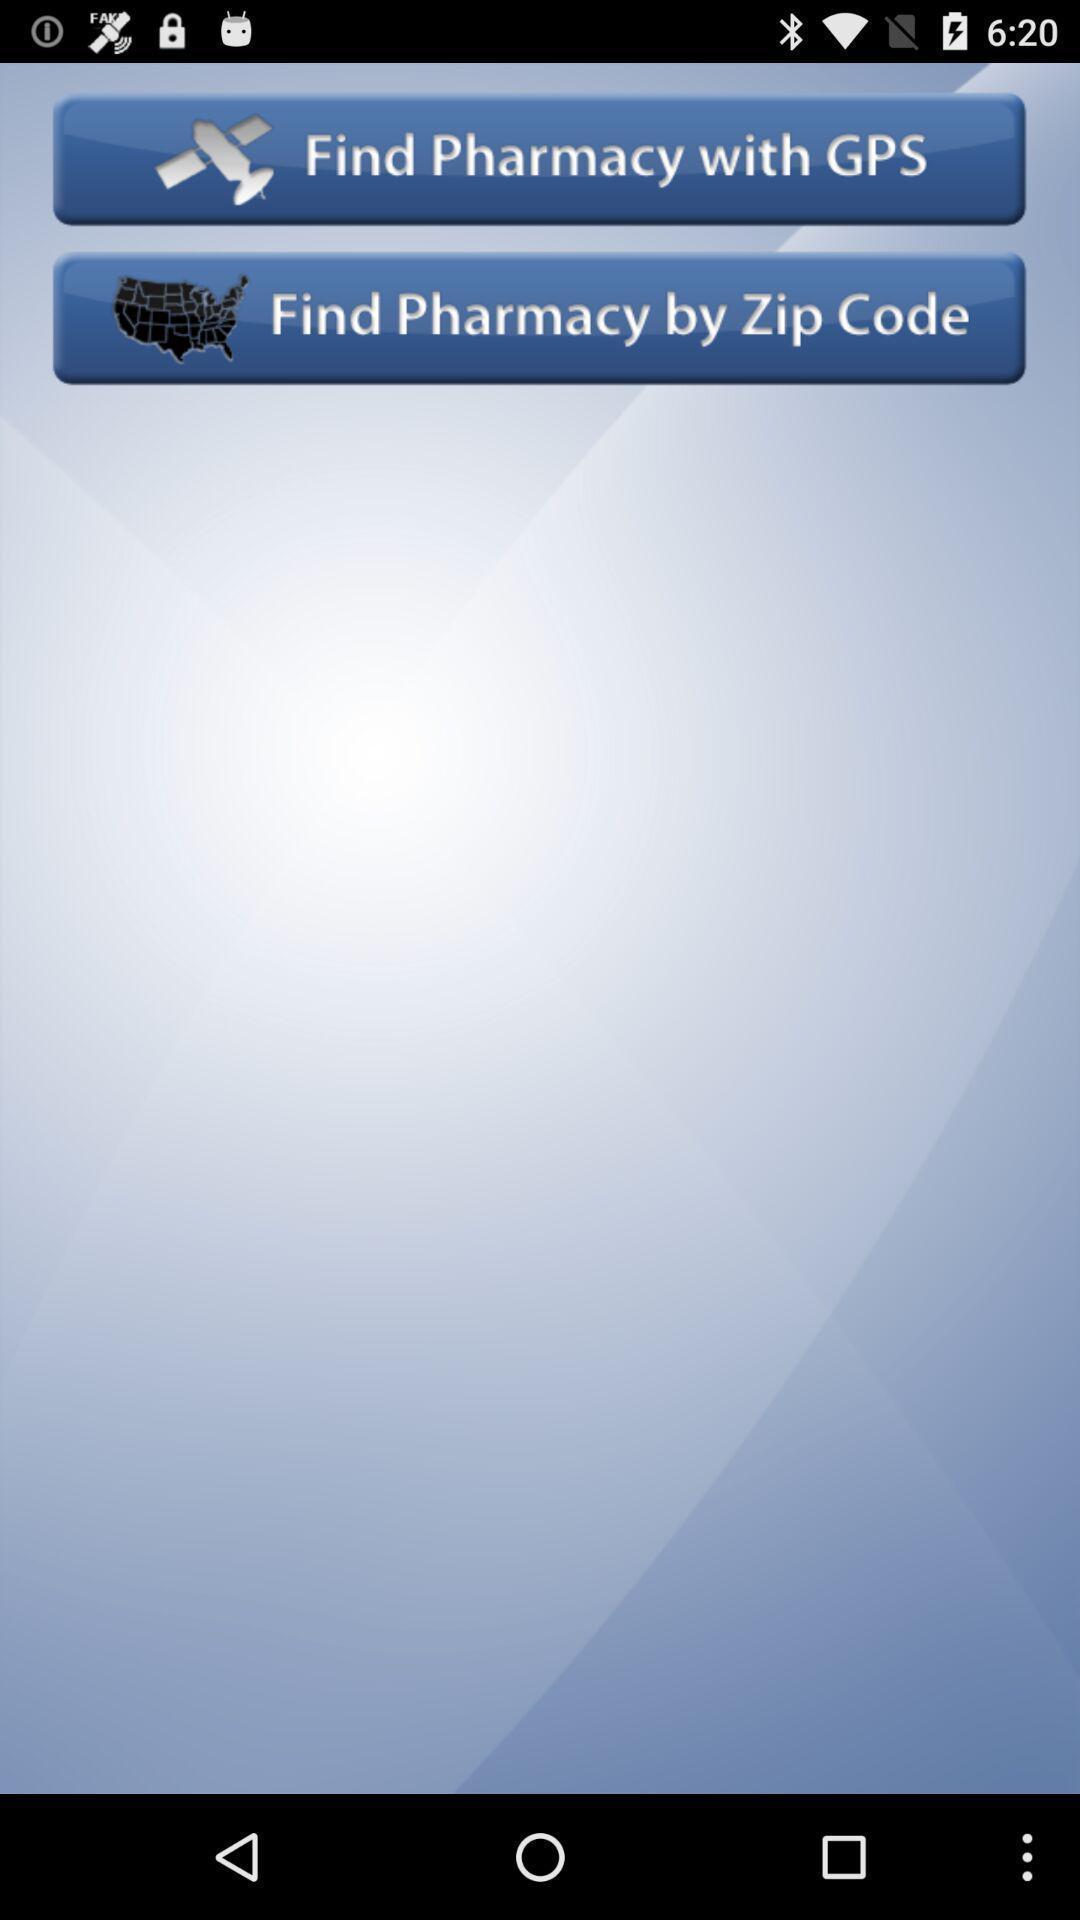Please provide a description for this image. Two options in finding a pharmacy location app. 